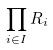Convert formula to latex. <formula><loc_0><loc_0><loc_500><loc_500>\prod _ { i \in I } R _ { i }</formula> 